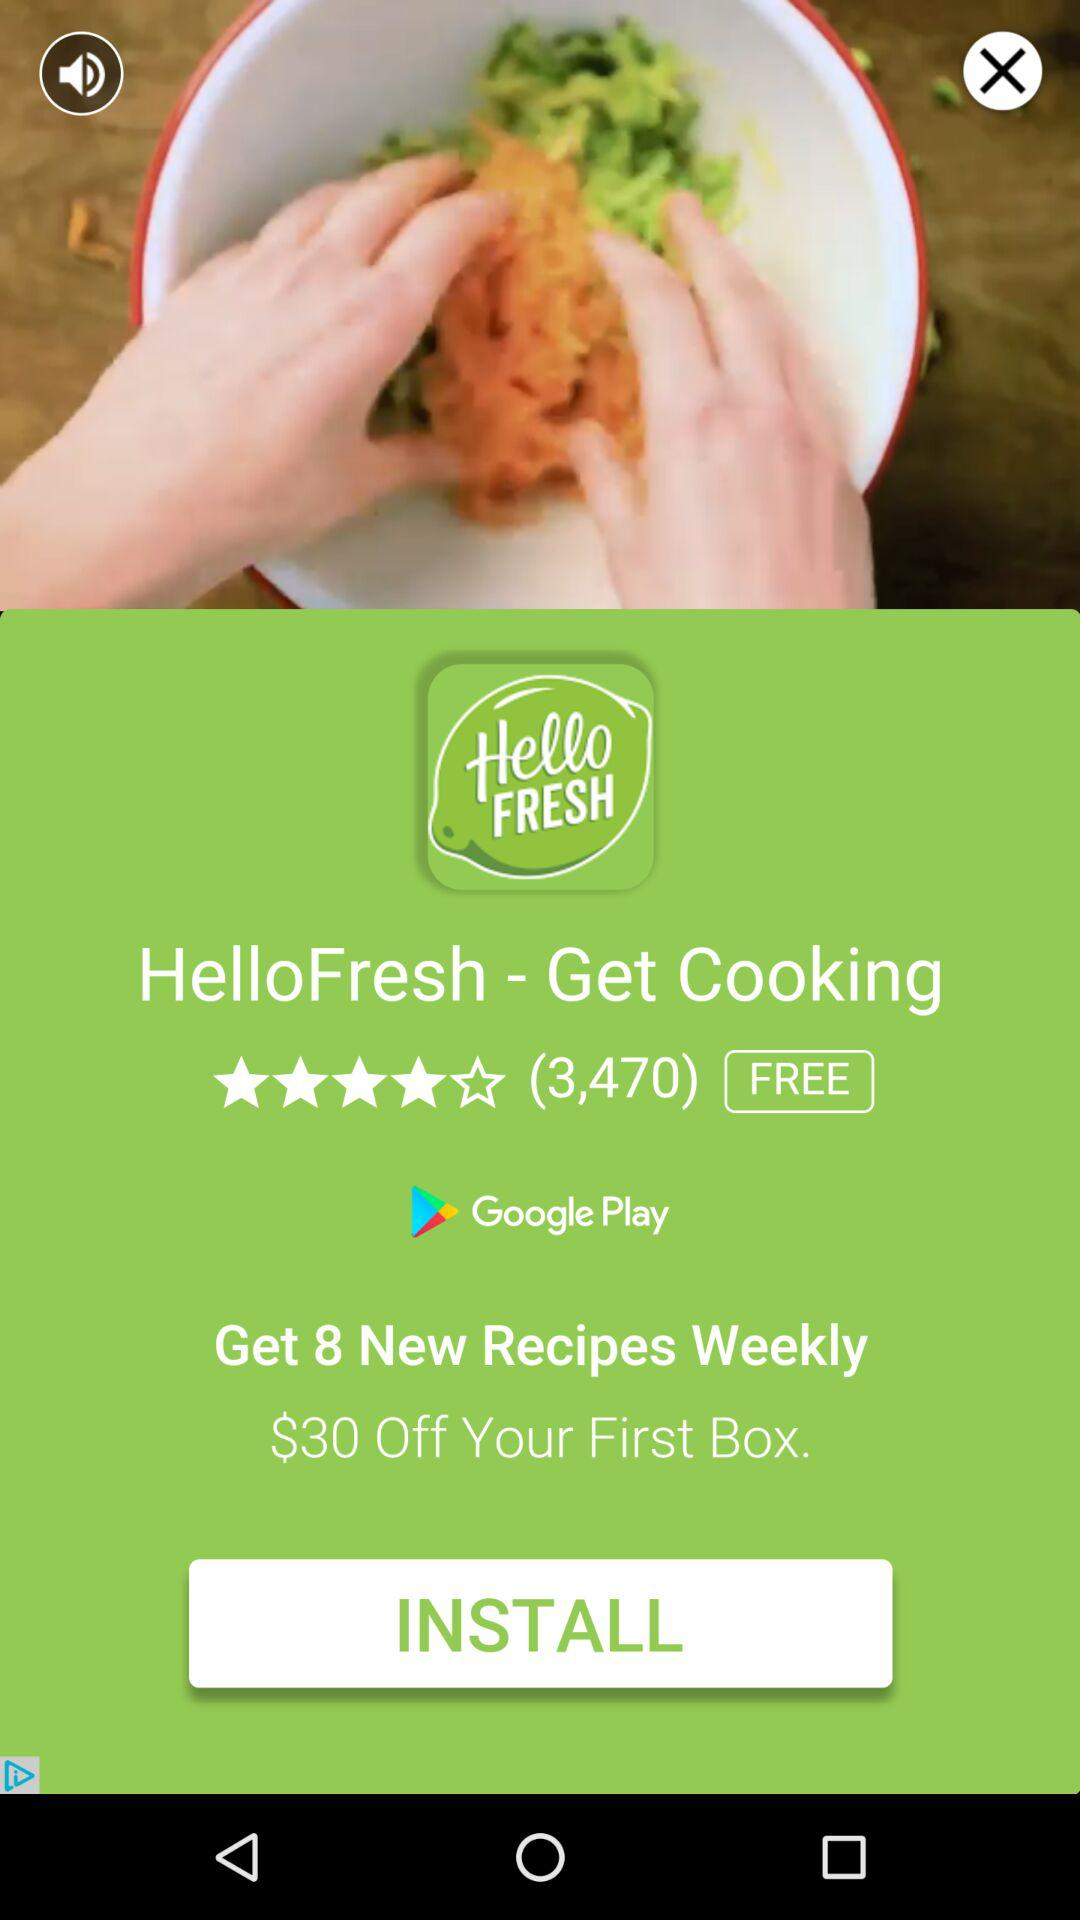How many dollars off is the HelloFresh app offering for a first time purchase?
Answer the question using a single word or phrase. $30 